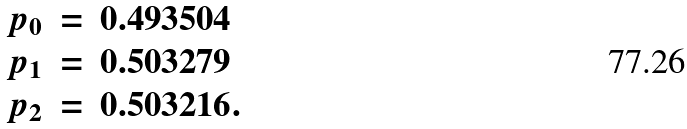<formula> <loc_0><loc_0><loc_500><loc_500>\begin{array} { r c l } p _ { 0 } & = & 0 . 4 9 3 5 0 4 \\ p _ { 1 } & = & 0 . 5 0 3 2 7 9 \\ p _ { 2 } & = & 0 . 5 0 3 2 1 6 . \end{array}</formula> 